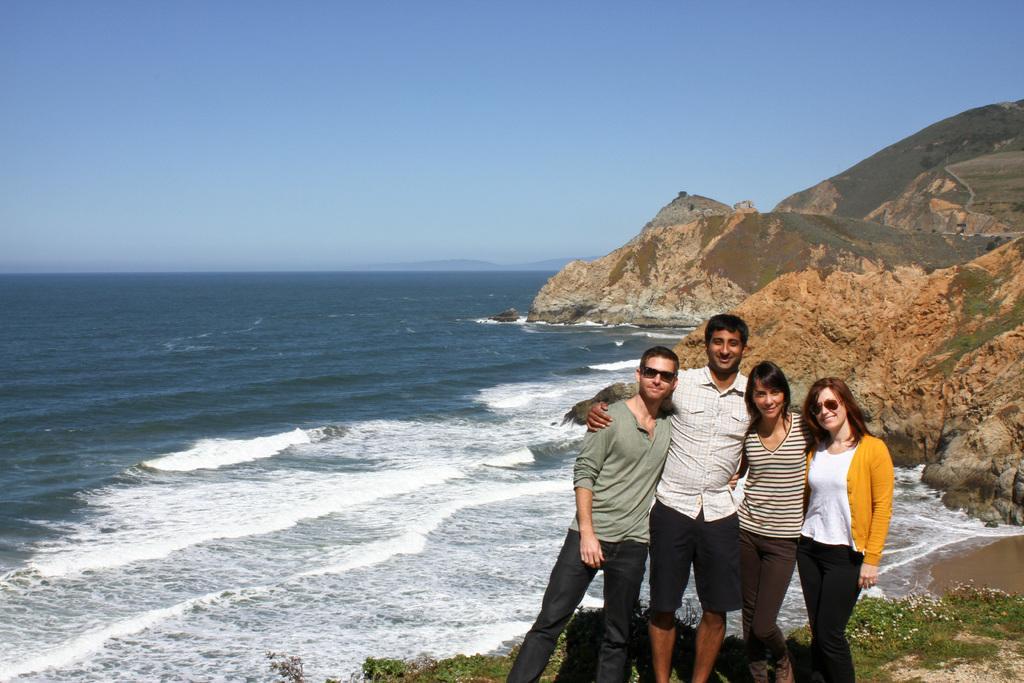Could you give a brief overview of what you see in this image? In the foreground of the image we can see four people are standing and taking photograph. In the middle of the image we can see water body and mountains. On the top of the image we can see the sky. 